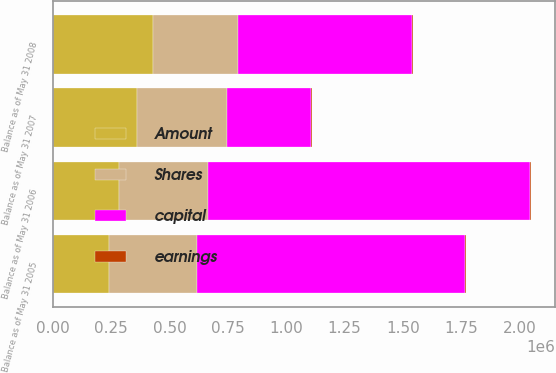<chart> <loc_0><loc_0><loc_500><loc_500><stacked_bar_chart><ecel><fcel>Balance as of May 31 2005<fcel>Balance as of May 31 2006<fcel>Balance as of May 31 2007<fcel>Balance as of May 31 2008<nl><fcel>Shares<fcel>378629<fcel>380303<fcel>382151<fcel>360500<nl><fcel>earnings<fcel>3786<fcel>3803<fcel>3822<fcel>3605<nl><fcel>Amount<fcel>240700<fcel>284395<fcel>362982<fcel>431639<nl><fcel>capital<fcel>1.14761e+06<fcel>1.38097e+06<fcel>362982<fcel>745351<nl></chart> 